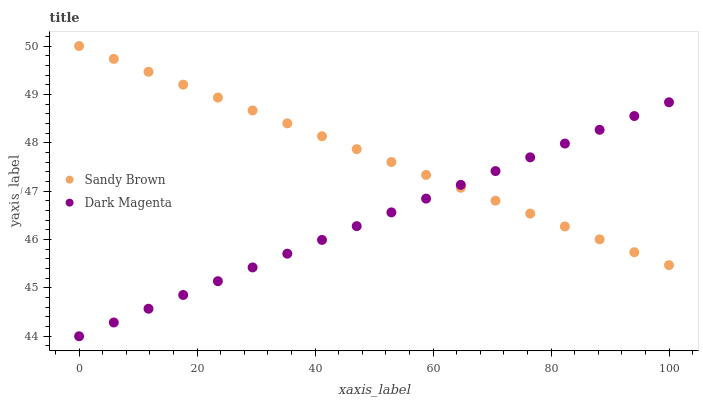Does Dark Magenta have the minimum area under the curve?
Answer yes or no. Yes. Does Sandy Brown have the maximum area under the curve?
Answer yes or no. Yes. Does Dark Magenta have the maximum area under the curve?
Answer yes or no. No. Is Dark Magenta the smoothest?
Answer yes or no. Yes. Is Sandy Brown the roughest?
Answer yes or no. Yes. Is Dark Magenta the roughest?
Answer yes or no. No. Does Dark Magenta have the lowest value?
Answer yes or no. Yes. Does Sandy Brown have the highest value?
Answer yes or no. Yes. Does Dark Magenta have the highest value?
Answer yes or no. No. Does Sandy Brown intersect Dark Magenta?
Answer yes or no. Yes. Is Sandy Brown less than Dark Magenta?
Answer yes or no. No. Is Sandy Brown greater than Dark Magenta?
Answer yes or no. No. 